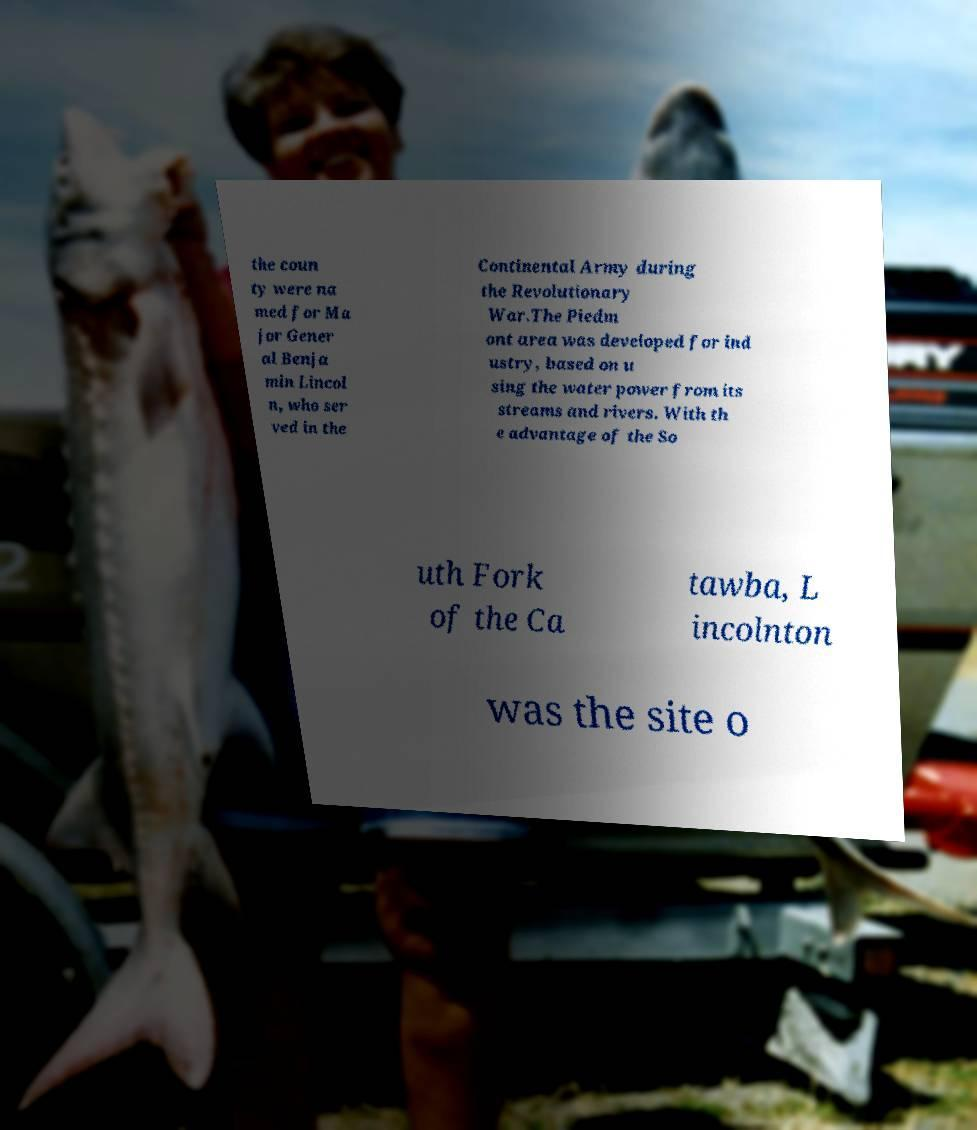For documentation purposes, I need the text within this image transcribed. Could you provide that? the coun ty were na med for Ma jor Gener al Benja min Lincol n, who ser ved in the Continental Army during the Revolutionary War.The Piedm ont area was developed for ind ustry, based on u sing the water power from its streams and rivers. With th e advantage of the So uth Fork of the Ca tawba, L incolnton was the site o 